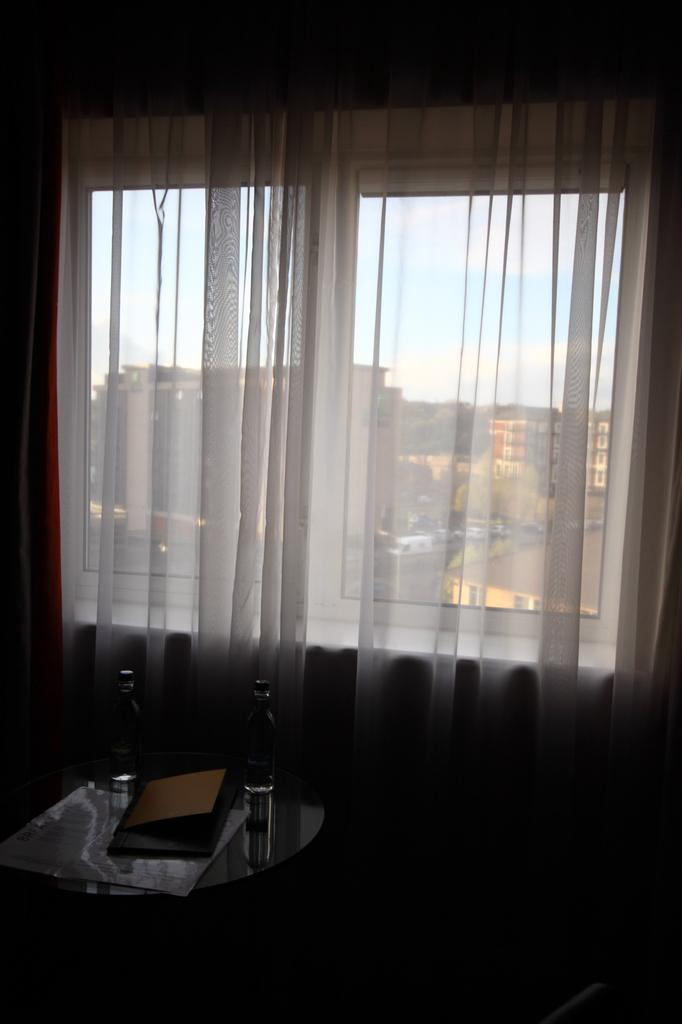What is located at the bottom of the picture? There is a table in the bottom of the picture. What can be seen in the middle of the picture? There is a window in the middle of the picture. What is associated with the window in the picture? There is a curtain associated with the window. What is visible in the background of the picture? There are buildings and the sky in the background of the picture. What type of badge is visible on the curtain in the image? There is no badge present on the curtain in the image. What is the income of the person who owns the buildings in the background? The income of the person who owns the buildings in the background cannot be determined from the image. 